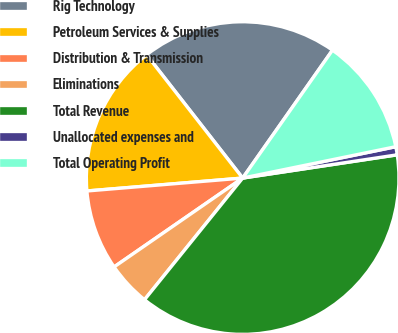<chart> <loc_0><loc_0><loc_500><loc_500><pie_chart><fcel>Rig Technology<fcel>Petroleum Services & Supplies<fcel>Distribution & Transmission<fcel>Eliminations<fcel>Total Revenue<fcel>Unallocated expenses and<fcel>Total Operating Profit<nl><fcel>20.28%<fcel>15.78%<fcel>8.31%<fcel>4.57%<fcel>38.18%<fcel>0.84%<fcel>12.04%<nl></chart> 